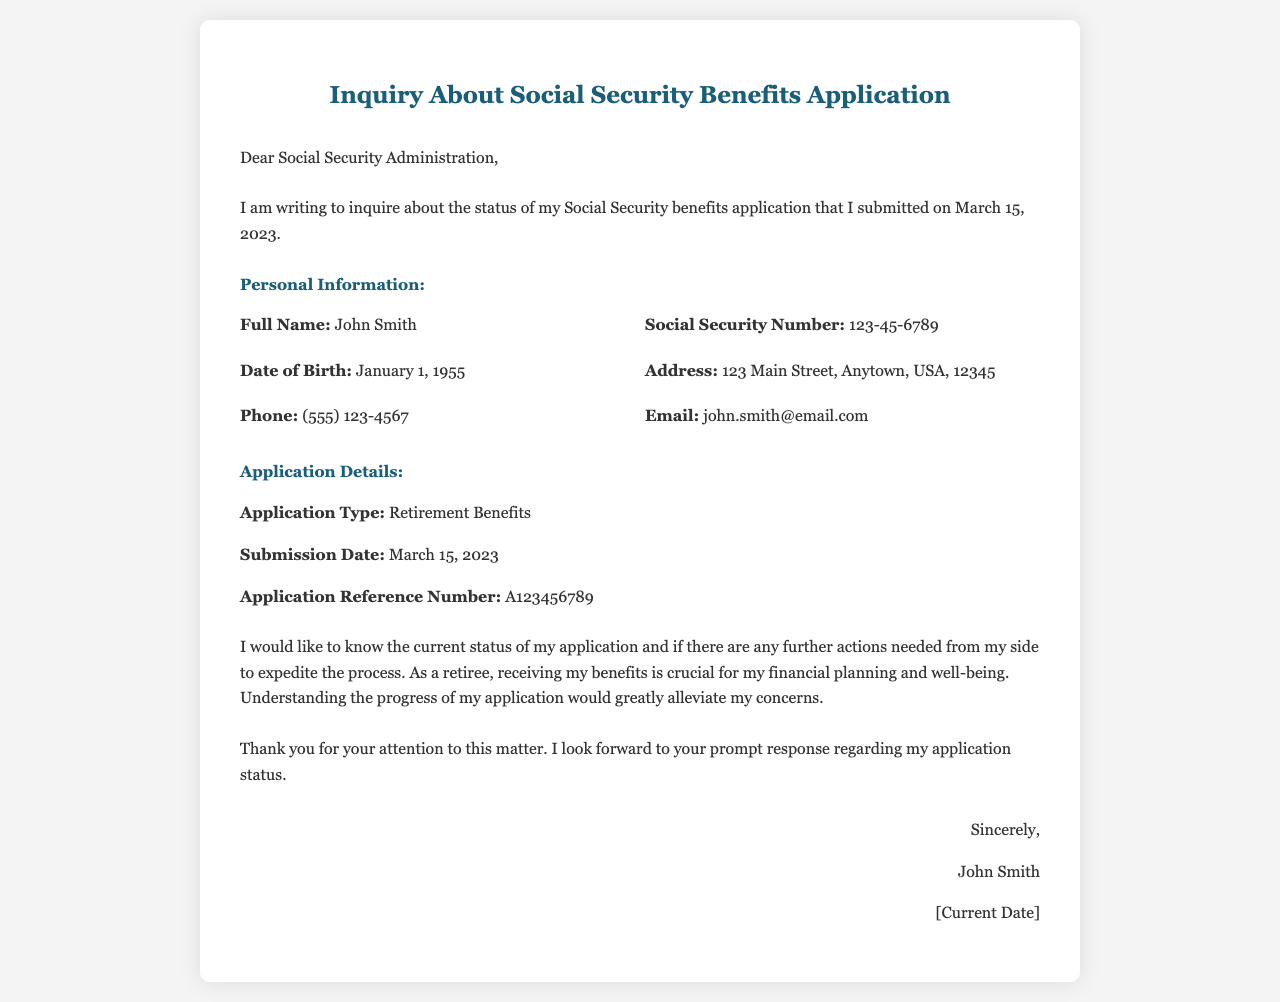What is the application submission date? The application submission date is explicitly stated in the document under "Submission Date."
Answer: March 15, 2023 What is the full name of the applicant? The full name of the applicant is provided in the "Personal Information" section.
Answer: John Smith What type of application is referenced in the document? The type of application is mentioned in the "Application Details" section as "Application Type."
Answer: Retirement Benefits What is the Social Security Number listed in the document? The Social Security Number is found in the "Personal Information" section.
Answer: 123-45-6789 What is the current date mentioned in the letter? The current date appears in the closing signature section as a placeholder for the signer's date.
Answer: [Current Date] What is the purpose of the letter? The purpose of the letter is summarized in the introduction, where the applicant states their intention.
Answer: To inquire about the status of the application What is the significance of receiving benefits according to the applicant? The applicant mentions the importance of benefits for their financial planning in the document.
Answer: Crucial for financial planning Is there a reference number for the application included in the document? The document states a specific number under "Application Reference Number."
Answer: A123456789 What does the applicant request from the Social Security Administration? The applicant explicitly asks for information regarding their application status in the letter.
Answer: Current status of my application 